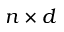<formula> <loc_0><loc_0><loc_500><loc_500>n \times d</formula> 